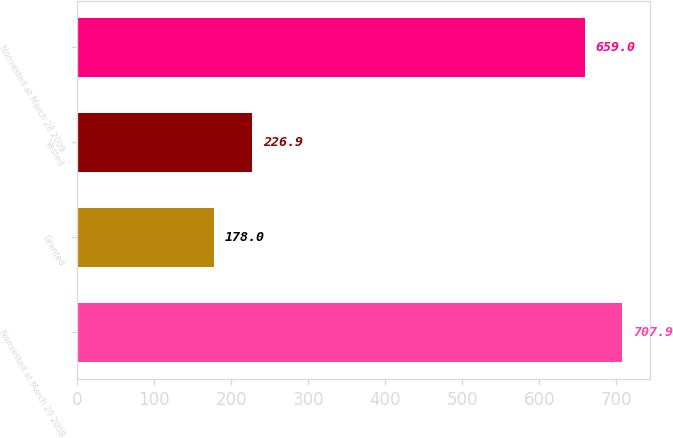Convert chart to OTSL. <chart><loc_0><loc_0><loc_500><loc_500><bar_chart><fcel>Nonvested at March 29 2008<fcel>Granted<fcel>Vested<fcel>Nonvested at March 28 2009<nl><fcel>707.9<fcel>178<fcel>226.9<fcel>659<nl></chart> 